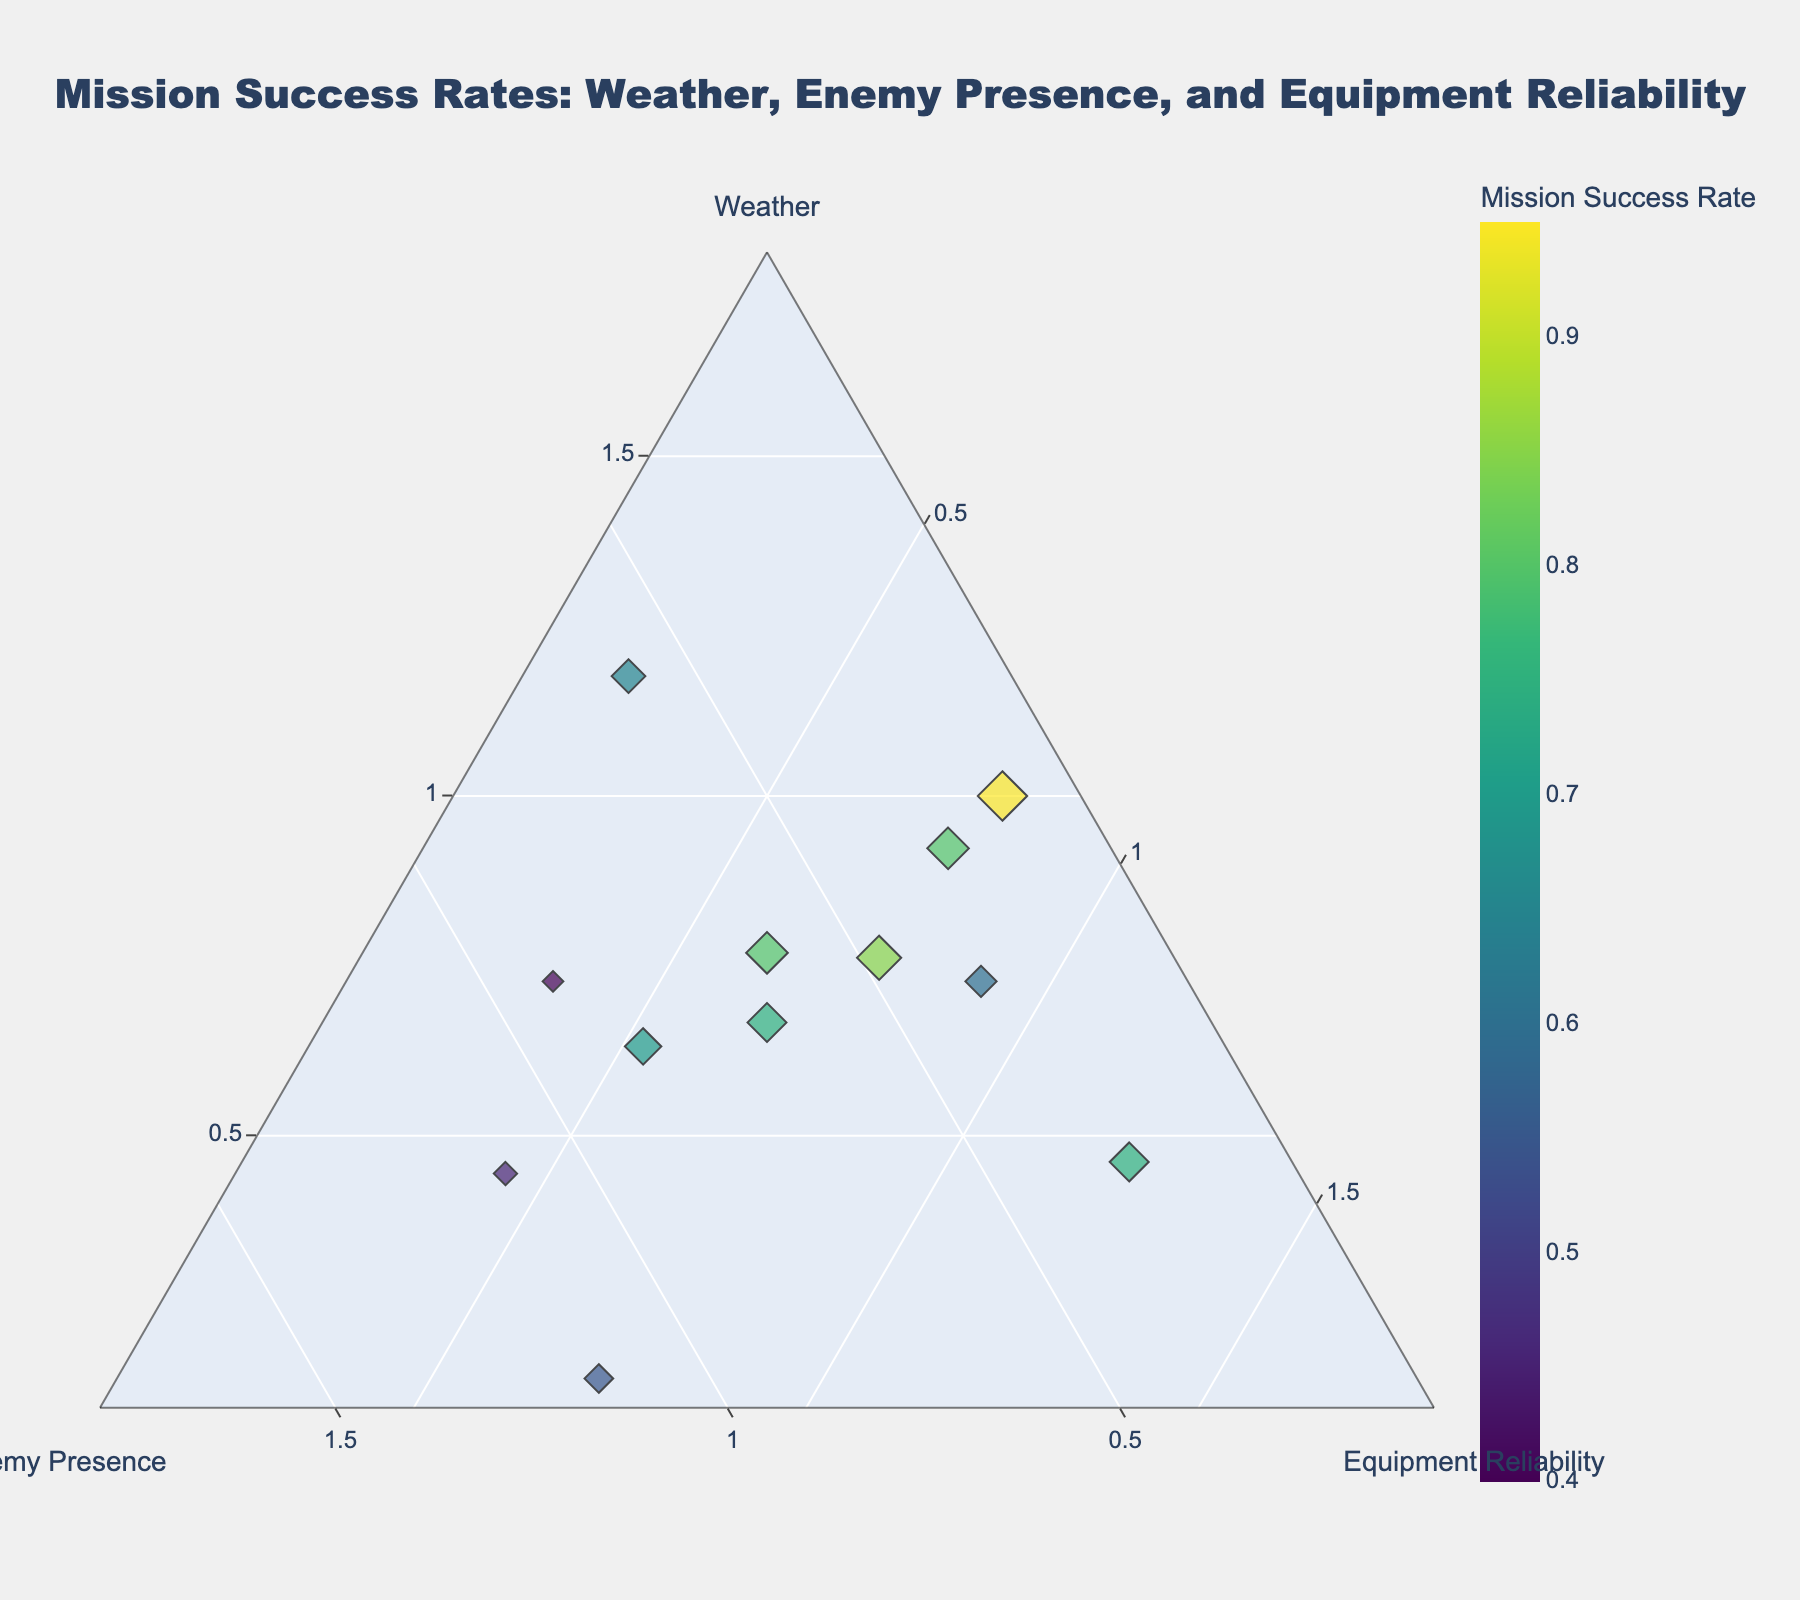What is the title of the figure? The title of the figure is prominently displayed at the top, easily noticeable through its larger font size. By reading the text at the top of the chart, we can identify the title.
Answer: Mission Success Rates: Weather, Enemy Presence, and Equipment Reliability How many data points are shown in the plot? The number of data points can be identified by counting the markers displayed on the ternary plot.
Answer: 12 Which weather condition is associated with the highest mission success rate? By examining the markers and their hover information, we find the marker with the highest mission success rate and note its associated weather condition.
Answer: Clear Skies What is the mission success rate when the enemy presence is high and the equipment reliability is high? By hovering over or examining markers where enemy presence and equipment reliability both map to high values, we find the specific mission success rate.
Answer: 0.80 Which combination of factors (weather, enemy presence, and equipment reliability) results in the lowest mission success rate? By identifying the marker with the smallest mission success rate and examining its hover information for its associated weather, enemy presence, and equipment reliability, we find the needed combination.
Answer: Thunderstorms, Moderate, Low Compare the mission success rates between clear skies with low enemy presence and thunderstorms with low enemy presence. Locate and compare the markers for these specific conditions by looking for "Clear Skies" with "Low" enemy presence and "Thunderstorms" with "Low" enemy presence. Compare the success rates from their hover information.
Answer: 0.95 (Clear Skies, Low) vs. 0.60 (Thunderstorms, Low) What impact does equipment reliability appear to have on mission success rates when weather conditions are clear skies? Examine markers associated with clear skies and compare the success rates across different levels of equipment reliability. Notice any patterns corresponding to changes in equipment reliability.
Answer: Higher equipment reliability tends to result in higher mission success rates What is the average mission success rate for overcast weather conditions? Find all markers associated with overcast weather, sum up their mission success rates, and divide by the number of such markers to find the average.
Answer: (0.70 + 0.80) / 2 = 0.75 Explain the trend in mission success rates with varying levels of enemy presence while equipment reliability is high. Filter markers where equipment reliability is high and note corresponding enemy presence levels, then observe and compare the associated success rates to identify any trends.
Answer: Higher enemy presence usually correlates with lower mission success rates Which weather condition sees the widest range in mission success rates, and what are those rates? Identify weather conditions with multiple markers and compare the range (difference between the highest and lowest success rates) for each condition. Annotate the widest range.
Answer: Clear Skies; rates: 0.95, 0.80, 0.65 (widest range of 0.30) 